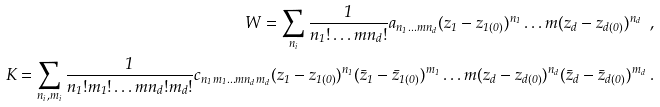<formula> <loc_0><loc_0><loc_500><loc_500>W = \sum _ { n _ { i } } \frac { 1 } { n _ { 1 } ! \dots m n _ { d } ! } a _ { n _ { 1 } \dots m n _ { d } } ( z _ { 1 } - z _ { 1 ( 0 ) } ) ^ { n _ { 1 } } \dots m ( z _ { d } - z _ { d ( 0 ) } ) ^ { n _ { d } } \ , \\ K = \sum _ { n _ { i } , m _ { i } } \frac { 1 } { n _ { 1 } ! m _ { 1 } ! \dots m n _ { d } ! m _ { d } ! } c _ { n _ { 1 } m _ { 1 } \dots m n _ { d } m _ { d } } ( z _ { 1 } - z _ { 1 ( 0 ) } ) ^ { n _ { 1 } } ( \bar { z } _ { 1 } - \bar { z } _ { 1 ( 0 ) } ) ^ { m _ { 1 } } \dots m ( z _ { d } - z _ { d ( 0 ) } ) ^ { n _ { d } } ( \bar { z } _ { d } - \bar { z } _ { d ( 0 ) } ) ^ { m _ { d } } \ .</formula> 